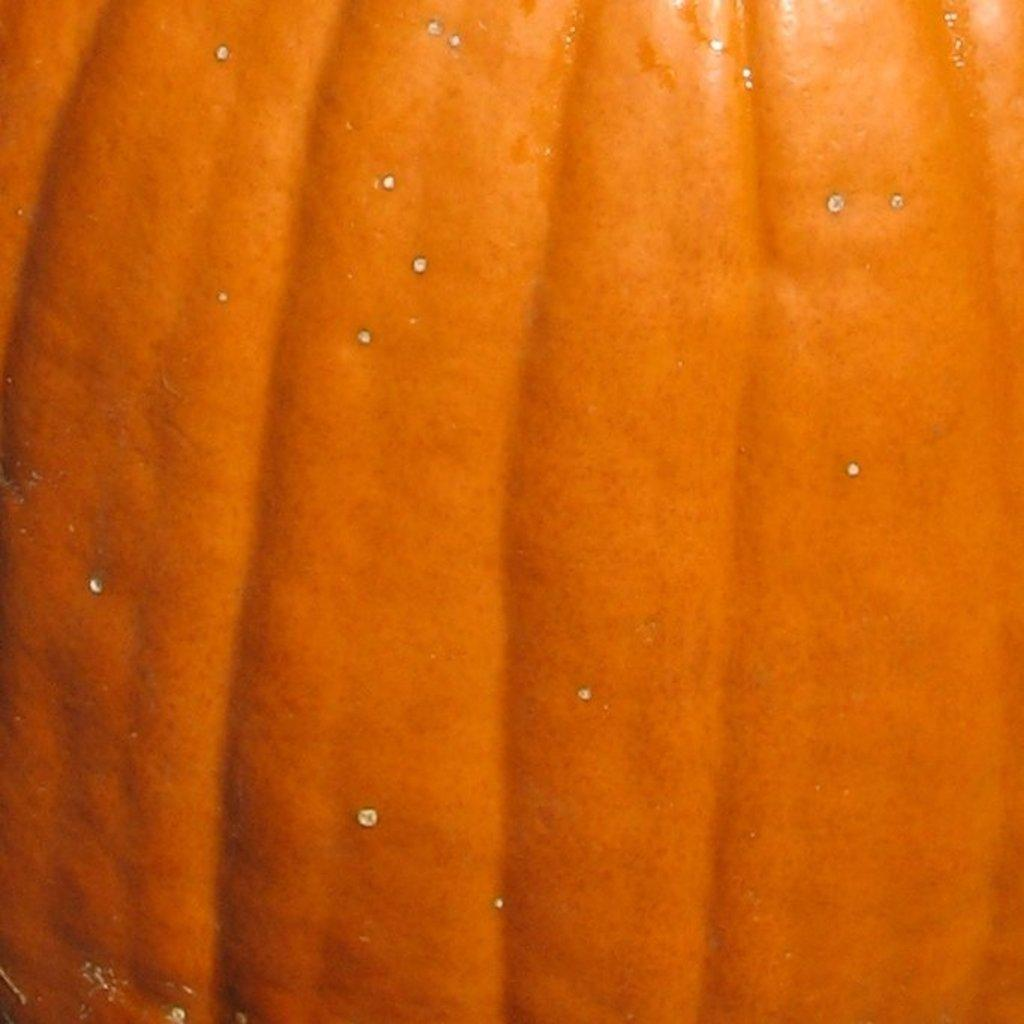What is the color of the main object in the image? The main object in the image is orange. What does the object in the image resemble? The object resembles a pumpkin. What type of wilderness can be seen in the background of the image? There is no wilderness visible in the image; it only features an orange object that resembles a pumpkin. 